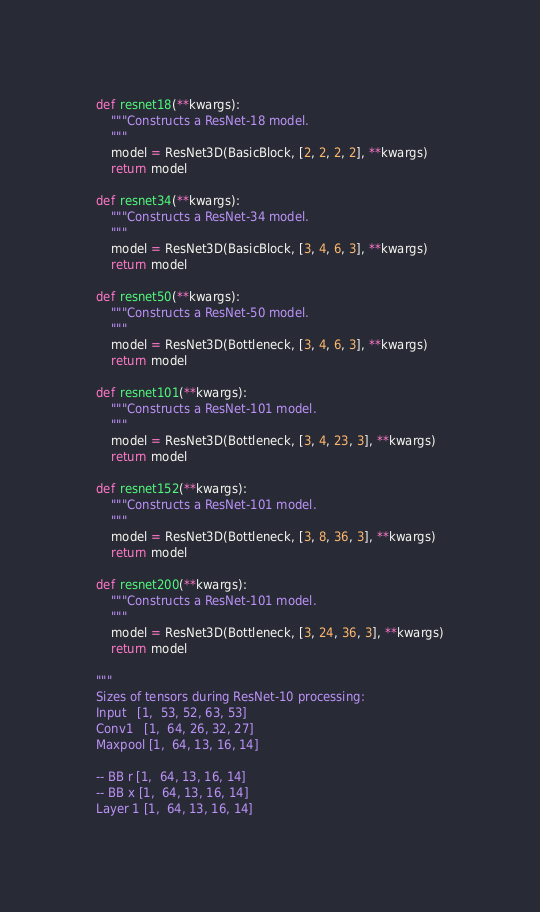<code> <loc_0><loc_0><loc_500><loc_500><_Python_>
def resnet18(**kwargs):
    """Constructs a ResNet-18 model.
    """
    model = ResNet3D(BasicBlock, [2, 2, 2, 2], **kwargs)
    return model

def resnet34(**kwargs):
    """Constructs a ResNet-34 model.
    """
    model = ResNet3D(BasicBlock, [3, 4, 6, 3], **kwargs)
    return model

def resnet50(**kwargs):
    """Constructs a ResNet-50 model.
    """
    model = ResNet3D(Bottleneck, [3, 4, 6, 3], **kwargs)
    return model

def resnet101(**kwargs):
    """Constructs a ResNet-101 model.
    """
    model = ResNet3D(Bottleneck, [3, 4, 23, 3], **kwargs)
    return model

def resnet152(**kwargs):
    """Constructs a ResNet-101 model.
    """
    model = ResNet3D(Bottleneck, [3, 8, 36, 3], **kwargs)
    return model

def resnet200(**kwargs):
    """Constructs a ResNet-101 model.
    """
    model = ResNet3D(Bottleneck, [3, 24, 36, 3], **kwargs)
    return model

"""
Sizes of tensors during ResNet-10 processing:
Input   [1,  53, 52, 63, 53]
Conv1   [1,  64, 26, 32, 27]
Maxpool [1,  64, 13, 16, 14]

-- BB r [1,  64, 13, 16, 14]
-- BB x [1,  64, 13, 16, 14]
Layer 1 [1,  64, 13, 16, 14]
</code> 